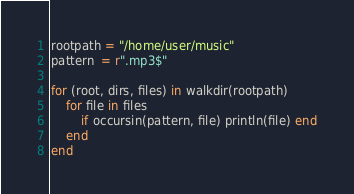Convert code to text. <code><loc_0><loc_0><loc_500><loc_500><_Julia_>rootpath = "/home/user/music"
pattern  = r".mp3$"

for (root, dirs, files) in walkdir(rootpath)
    for file in files
        if occursin(pattern, file) println(file) end
    end
end
</code> 